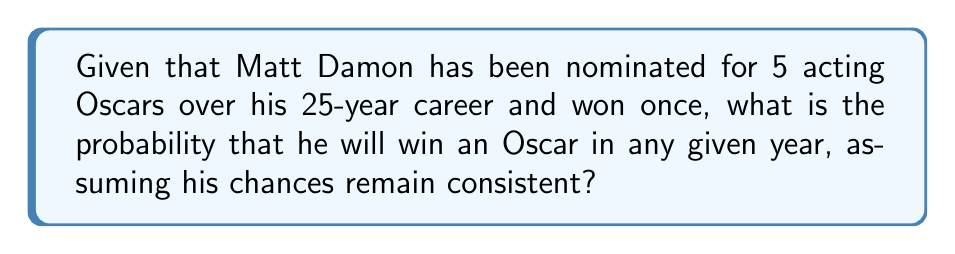Help me with this question. To calculate the probability of Matt Damon winning an Oscar in a given year, we need to follow these steps:

1. Determine the number of Oscar wins: 1
2. Determine the number of years in his career: 25
3. Calculate the probability using the formula:

   $P(\text{winning in a year}) = \frac{\text{Number of wins}}{\text{Number of years}}$

4. Plug in the values:

   $P(\text{winning in a year}) = \frac{1}{25}$

5. Simplify the fraction:

   $P(\text{winning in a year}) = 0.04$

This means that, based on his past performance and assuming consistent chances, Matt Damon has a 4% probability of winning an Oscar in any given year.

Note: This calculation assumes that his chances of winning remain constant over time and that past performance is indicative of future results, which may not always be the case in the dynamic world of Hollywood.
Answer: $\frac{1}{25}$ or $0.04$ or $4\%$ 